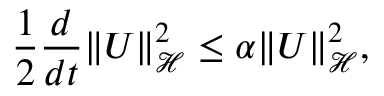Convert formula to latex. <formula><loc_0><loc_0><loc_500><loc_500>\frac { 1 } { 2 } \frac { d } { d t } \| U \| _ { \mathcal { H } } ^ { 2 } \leq \alpha \| U \| _ { \mathcal { H } } ^ { 2 } ,</formula> 